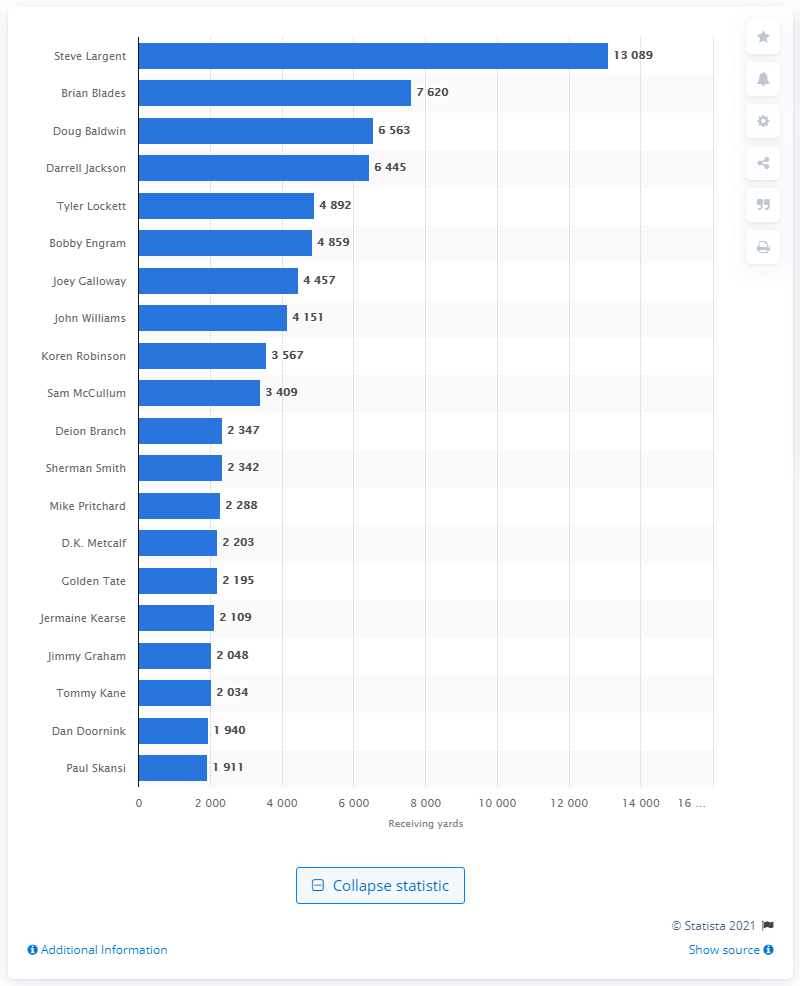Outline some significant characteristics in this image. Steve Largent is the career receiving leader of the Seattle Seahawks. 